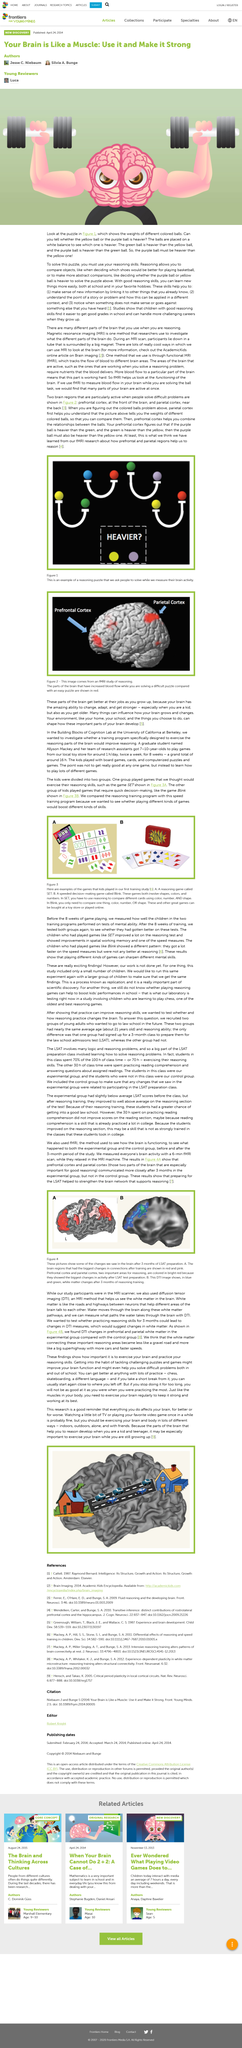Draw attention to some important aspects in this diagram. The two fMRI measurements occurred over a three-month period. It is more important to exercise a child's brain than to focus on their physical development, as the parts of the brain responsible for reasoning and critical thinking develop during childhood. The prefrontal cortex and parietal cortex experienced the most significant changes in activity during the study. It is recommended that individuals engage in diverse cognitive activities to keep their brains healthy, including both passive activities such as watching TV and playing games, as well as more active forms of exercise such as indoor and outdoor activities, and solitary or social pursuits. The experimental group studied for the LSAT. 